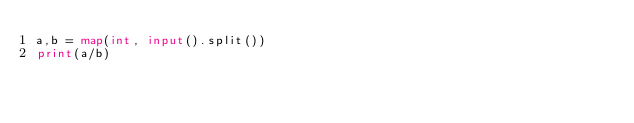<code> <loc_0><loc_0><loc_500><loc_500><_Python_>a,b = map(int, input().split())
print(a/b)</code> 